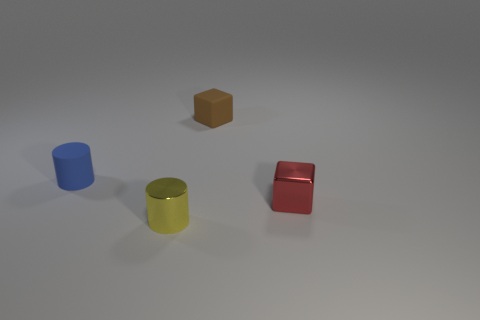What number of things are either metal cylinders that are in front of the red metallic block or small things in front of the red cube?
Your answer should be very brief. 1. There is a yellow cylinder that is the same size as the red thing; what is it made of?
Make the answer very short. Metal. What number of other things are there of the same material as the blue object
Make the answer very short. 1. Are there the same number of tiny yellow shiny cylinders that are behind the small brown cube and tiny red objects that are on the left side of the blue rubber thing?
Provide a succinct answer. Yes. What number of brown objects are rubber balls or tiny metallic blocks?
Offer a very short reply. 0. Are there fewer red metallic blocks than tiny gray metal things?
Provide a short and direct response. No. How many yellow things are to the left of the small cylinder in front of the small metallic object behind the yellow cylinder?
Provide a short and direct response. 0. Do the rubber thing behind the small blue rubber thing and the blue rubber object have the same shape?
Provide a short and direct response. No. There is a tiny brown thing that is the same shape as the red metallic object; what is its material?
Offer a very short reply. Rubber. Is there a small green sphere?
Provide a succinct answer. No. 